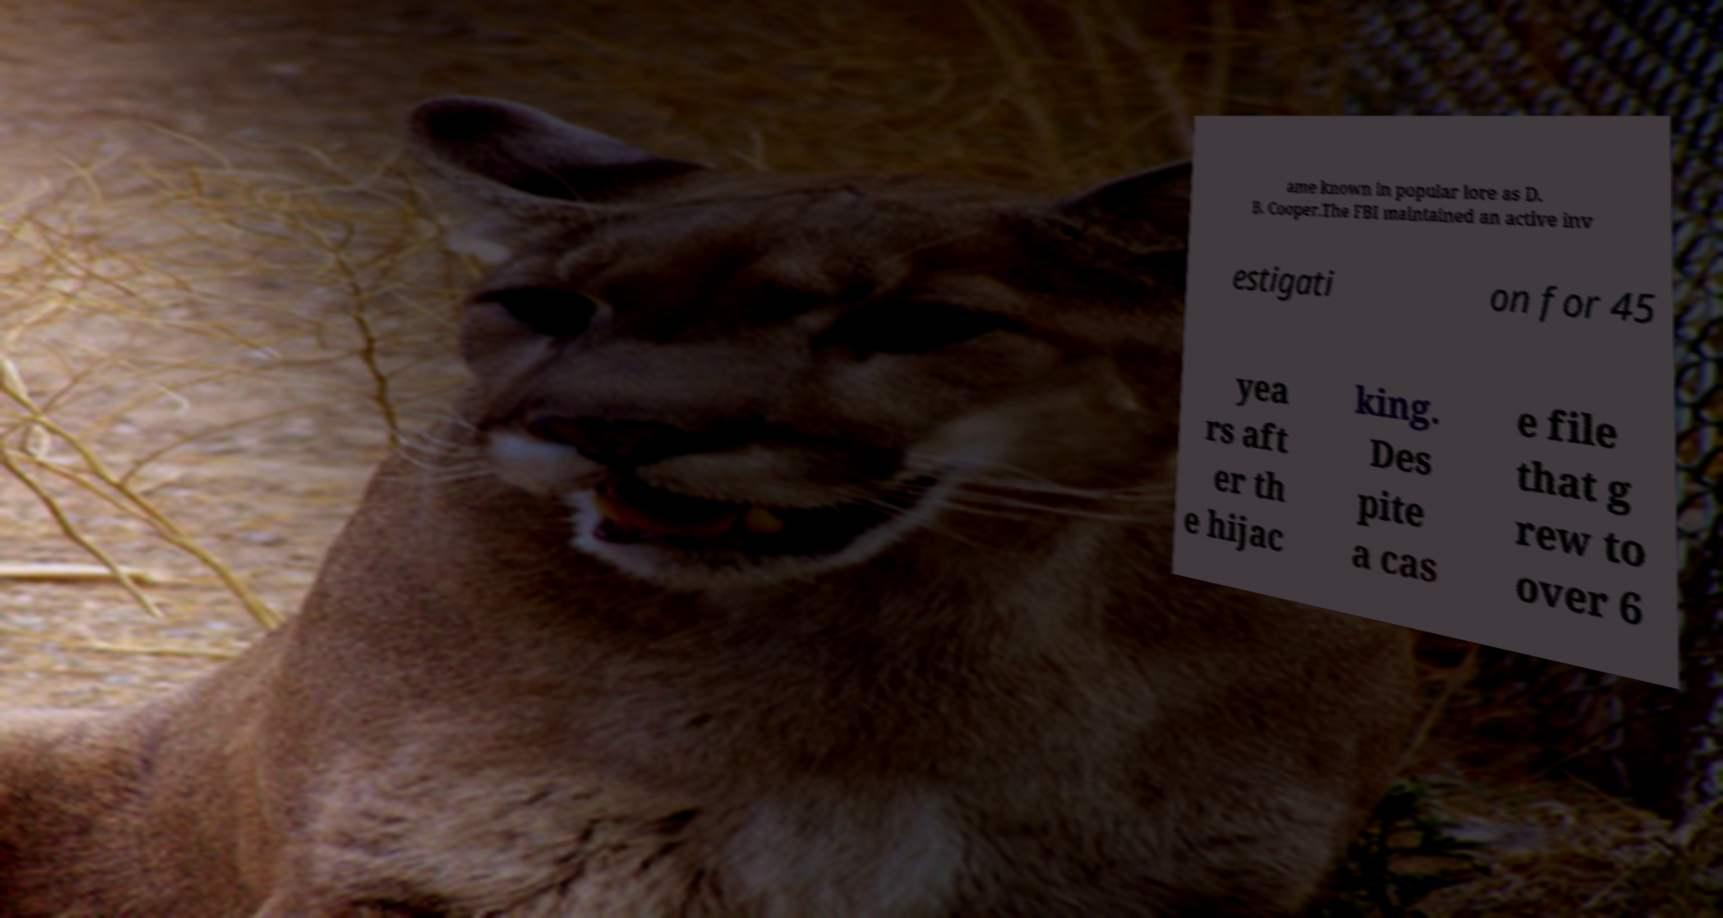Could you extract and type out the text from this image? ame known in popular lore as D. B. Cooper.The FBI maintained an active inv estigati on for 45 yea rs aft er th e hijac king. Des pite a cas e file that g rew to over 6 